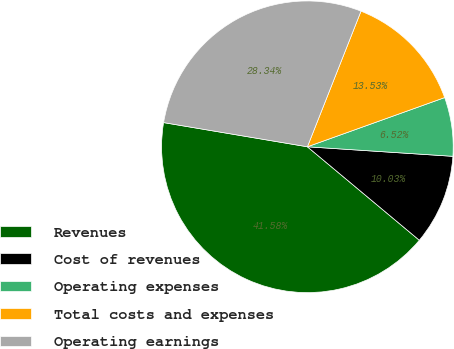<chart> <loc_0><loc_0><loc_500><loc_500><pie_chart><fcel>Revenues<fcel>Cost of revenues<fcel>Operating expenses<fcel>Total costs and expenses<fcel>Operating earnings<nl><fcel>41.58%<fcel>10.03%<fcel>6.52%<fcel>13.53%<fcel>28.34%<nl></chart> 